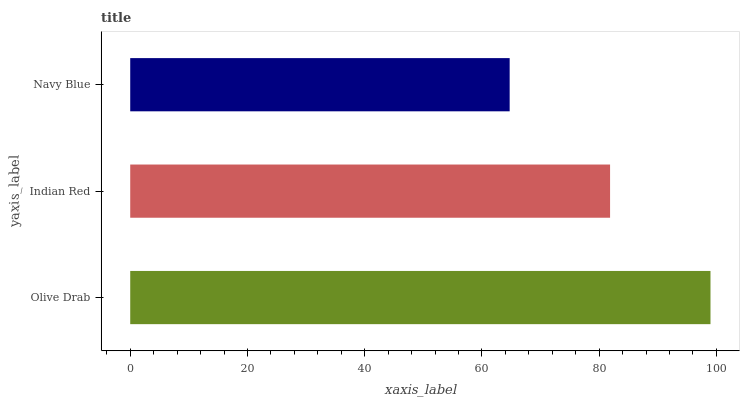Is Navy Blue the minimum?
Answer yes or no. Yes. Is Olive Drab the maximum?
Answer yes or no. Yes. Is Indian Red the minimum?
Answer yes or no. No. Is Indian Red the maximum?
Answer yes or no. No. Is Olive Drab greater than Indian Red?
Answer yes or no. Yes. Is Indian Red less than Olive Drab?
Answer yes or no. Yes. Is Indian Red greater than Olive Drab?
Answer yes or no. No. Is Olive Drab less than Indian Red?
Answer yes or no. No. Is Indian Red the high median?
Answer yes or no. Yes. Is Indian Red the low median?
Answer yes or no. Yes. Is Navy Blue the high median?
Answer yes or no. No. Is Navy Blue the low median?
Answer yes or no. No. 